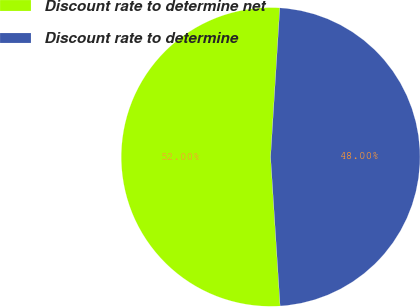<chart> <loc_0><loc_0><loc_500><loc_500><pie_chart><fcel>Discount rate to determine net<fcel>Discount rate to determine<nl><fcel>52.0%<fcel>48.0%<nl></chart> 